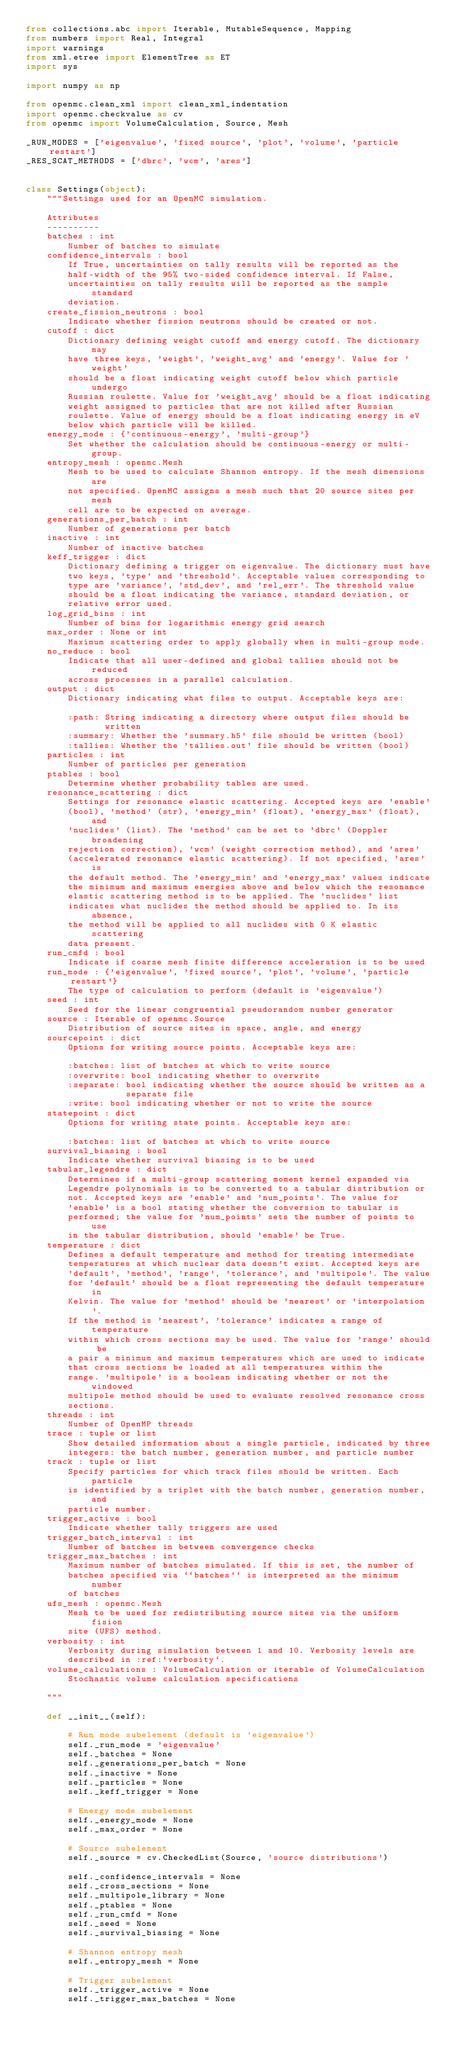<code> <loc_0><loc_0><loc_500><loc_500><_Python_>from collections.abc import Iterable, MutableSequence, Mapping
from numbers import Real, Integral
import warnings
from xml.etree import ElementTree as ET
import sys

import numpy as np

from openmc.clean_xml import clean_xml_indentation
import openmc.checkvalue as cv
from openmc import VolumeCalculation, Source, Mesh

_RUN_MODES = ['eigenvalue', 'fixed source', 'plot', 'volume', 'particle restart']
_RES_SCAT_METHODS = ['dbrc', 'wcm', 'ares']


class Settings(object):
    """Settings used for an OpenMC simulation.

    Attributes
    ----------
    batches : int
        Number of batches to simulate
    confidence_intervals : bool
        If True, uncertainties on tally results will be reported as the
        half-width of the 95% two-sided confidence interval. If False,
        uncertainties on tally results will be reported as the sample standard
        deviation.
    create_fission_neutrons : bool
        Indicate whether fission neutrons should be created or not.
    cutoff : dict
        Dictionary defining weight cutoff and energy cutoff. The dictionary may
        have three keys, 'weight', 'weight_avg' and 'energy'. Value for 'weight'
        should be a float indicating weight cutoff below which particle undergo
        Russian roulette. Value for 'weight_avg' should be a float indicating
        weight assigned to particles that are not killed after Russian
        roulette. Value of energy should be a float indicating energy in eV
        below which particle will be killed.
    energy_mode : {'continuous-energy', 'multi-group'}
        Set whether the calculation should be continuous-energy or multi-group.
    entropy_mesh : openmc.Mesh
        Mesh to be used to calculate Shannon entropy. If the mesh dimensions are
        not specified. OpenMC assigns a mesh such that 20 source sites per mesh
        cell are to be expected on average.
    generations_per_batch : int
        Number of generations per batch
    inactive : int
        Number of inactive batches
    keff_trigger : dict
        Dictionary defining a trigger on eigenvalue. The dictionary must have
        two keys, 'type' and 'threshold'. Acceptable values corresponding to
        type are 'variance', 'std_dev', and 'rel_err'. The threshold value
        should be a float indicating the variance, standard deviation, or
        relative error used.
    log_grid_bins : int
        Number of bins for logarithmic energy grid search
    max_order : None or int
        Maximum scattering order to apply globally when in multi-group mode.
    no_reduce : bool
        Indicate that all user-defined and global tallies should not be reduced
        across processes in a parallel calculation.
    output : dict
        Dictionary indicating what files to output. Acceptable keys are:

        :path: String indicating a directory where output files should be
               written
        :summary: Whether the 'summary.h5' file should be written (bool)
        :tallies: Whether the 'tallies.out' file should be written (bool)
    particles : int
        Number of particles per generation
    ptables : bool
        Determine whether probability tables are used.
    resonance_scattering : dict
        Settings for resonance elastic scattering. Accepted keys are 'enable'
        (bool), 'method' (str), 'energy_min' (float), 'energy_max' (float), and
        'nuclides' (list). The 'method' can be set to 'dbrc' (Doppler broadening
        rejection correction), 'wcm' (weight correction method), and 'ares'
        (accelerated resonance elastic scattering). If not specified, 'ares' is
        the default method. The 'energy_min' and 'energy_max' values indicate
        the minimum and maximum energies above and below which the resonance
        elastic scattering method is to be applied. The 'nuclides' list
        indicates what nuclides the method should be applied to. In its absence,
        the method will be applied to all nuclides with 0 K elastic scattering
        data present.
    run_cmfd : bool
        Indicate if coarse mesh finite difference acceleration is to be used
    run_mode : {'eigenvalue', 'fixed source', 'plot', 'volume', 'particle restart'}
        The type of calculation to perform (default is 'eigenvalue')
    seed : int
        Seed for the linear congruential pseudorandom number generator
    source : Iterable of openmc.Source
        Distribution of source sites in space, angle, and energy
    sourcepoint : dict
        Options for writing source points. Acceptable keys are:

        :batches: list of batches at which to write source
        :overwrite: bool indicating whether to overwrite
        :separate: bool indicating whether the source should be written as a
                   separate file
        :write: bool indicating whether or not to write the source
    statepoint : dict
        Options for writing state points. Acceptable keys are:

        :batches: list of batches at which to write source
    survival_biasing : bool
        Indicate whether survival biasing is to be used
    tabular_legendre : dict
        Determines if a multi-group scattering moment kernel expanded via
        Legendre polynomials is to be converted to a tabular distribution or
        not. Accepted keys are 'enable' and 'num_points'. The value for
        'enable' is a bool stating whether the conversion to tabular is
        performed; the value for 'num_points' sets the number of points to use
        in the tabular distribution, should 'enable' be True.
    temperature : dict
        Defines a default temperature and method for treating intermediate
        temperatures at which nuclear data doesn't exist. Accepted keys are
        'default', 'method', 'range', 'tolerance', and 'multipole'. The value
        for 'default' should be a float representing the default temperature in
        Kelvin. The value for 'method' should be 'nearest' or 'interpolation'.
        If the method is 'nearest', 'tolerance' indicates a range of temperature
        within which cross sections may be used. The value for 'range' should be
        a pair a minimum and maximum temperatures which are used to indicate
        that cross sections be loaded at all temperatures within the
        range. 'multipole' is a boolean indicating whether or not the windowed
        multipole method should be used to evaluate resolved resonance cross
        sections.
    threads : int
        Number of OpenMP threads
    trace : tuple or list
        Show detailed information about a single particle, indicated by three
        integers: the batch number, generation number, and particle number
    track : tuple or list
        Specify particles for which track files should be written. Each particle
        is identified by a triplet with the batch number, generation number, and
        particle number.
    trigger_active : bool
        Indicate whether tally triggers are used
    trigger_batch_interval : int
        Number of batches in between convergence checks
    trigger_max_batches : int
        Maximum number of batches simulated. If this is set, the number of
        batches specified via ``batches`` is interpreted as the minimum number
        of batches
    ufs_mesh : openmc.Mesh
        Mesh to be used for redistributing source sites via the uniform fision
        site (UFS) method.
    verbosity : int
        Verbosity during simulation between 1 and 10. Verbosity levels are
        described in :ref:`verbosity`.
    volume_calculations : VolumeCalculation or iterable of VolumeCalculation
        Stochastic volume calculation specifications

    """

    def __init__(self):

        # Run mode subelement (default is 'eigenvalue')
        self._run_mode = 'eigenvalue'
        self._batches = None
        self._generations_per_batch = None
        self._inactive = None
        self._particles = None
        self._keff_trigger = None

        # Energy mode subelement
        self._energy_mode = None
        self._max_order = None

        # Source subelement
        self._source = cv.CheckedList(Source, 'source distributions')

        self._confidence_intervals = None
        self._cross_sections = None
        self._multipole_library = None
        self._ptables = None
        self._run_cmfd = None
        self._seed = None
        self._survival_biasing = None

        # Shannon entropy mesh
        self._entropy_mesh = None

        # Trigger subelement
        self._trigger_active = None
        self._trigger_max_batches = None</code> 